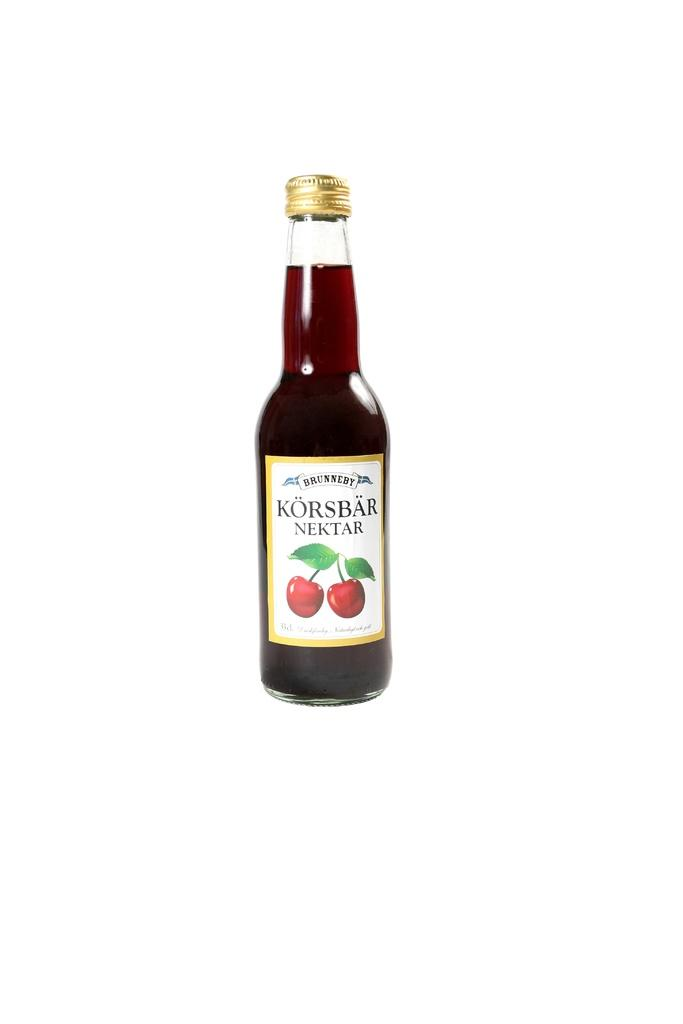What object is present in the image that contains a drink? There is a bottle in the image that contains a drink. Is there any additional information about the bottle? Yes, there is a sticker pasted to the bottle. What is depicted on the sticker? The sticker depicts two fruits. What type of jeans is the person wearing in the image? There is no person wearing jeans in the image; it only features a bottle with a sticker depicting two fruits. 